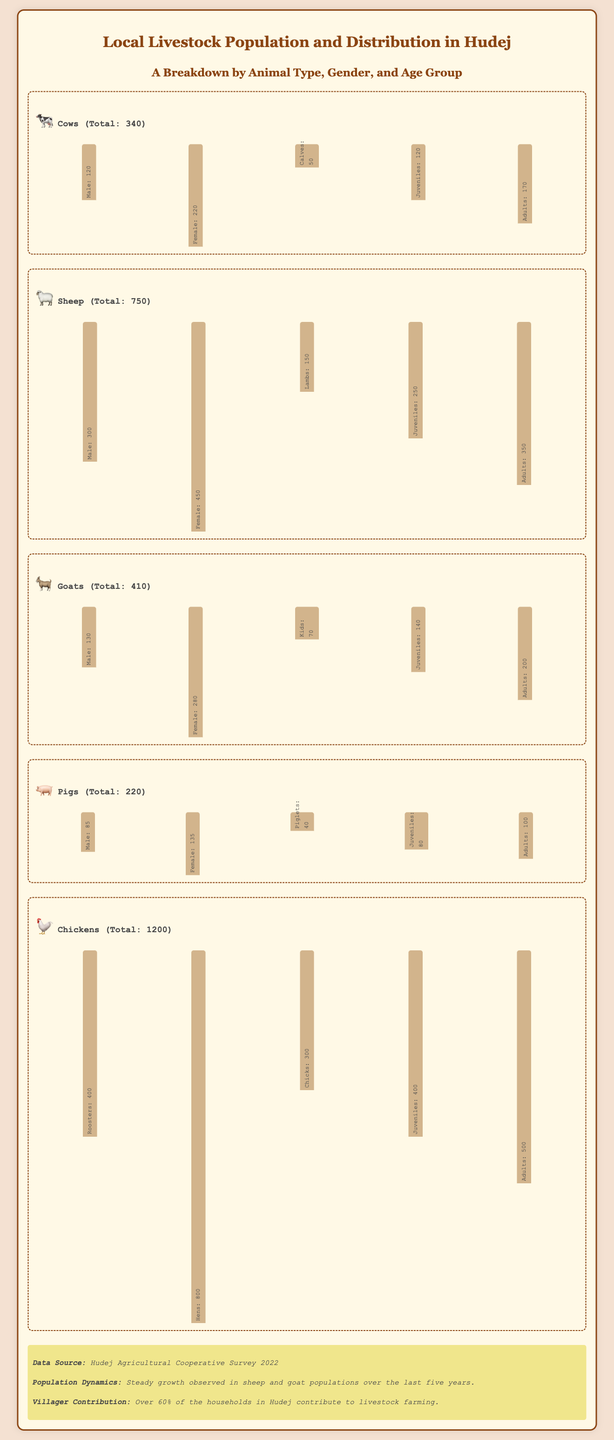What is the total number of cows in Hudej? The document states that the total number of cows is 340.
Answer: 340 How many male sheep are there? The infographic shows that there are 300 male sheep.
Answer: 300 What is the number of adult goats? The number of adult goats listed in the document is 200.
Answer: 200 Which animal type has the highest female population? The infographic indicates that chickens have the highest female population at 800.
Answer: Chickens What percentage of households in Hudej contribute to livestock farming? According to the document, over 60% of households contribute to livestock farming.
Answer: Over 60% How many piglets are there? The document specifies that there are 40 piglets.
Answer: 40 What animal has the lowest total population? The infographic shows that pigs have the lowest total population at 220.
Answer: Pigs How many total lambs are there? The total number of lambs mentioned is 150.
Answer: 150 Which age group has the highest number among chickens? The document states that hens have the highest number among chickens at 800.
Answer: Hens 